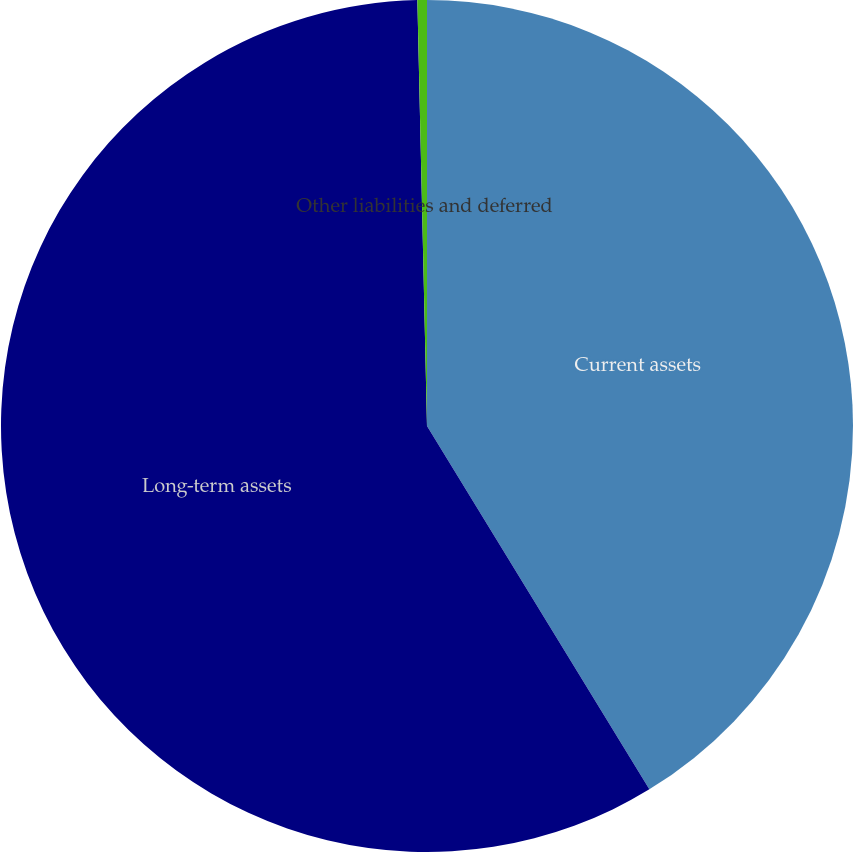Convert chart. <chart><loc_0><loc_0><loc_500><loc_500><pie_chart><fcel>Current assets<fcel>Long-term assets<fcel>Other liabilities and deferred<nl><fcel>41.26%<fcel>58.38%<fcel>0.36%<nl></chart> 